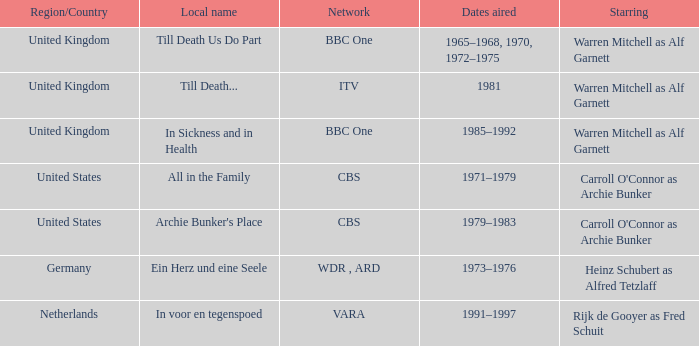What dates did the episodes air in the United States? 1971–1979, 1979–1983. 